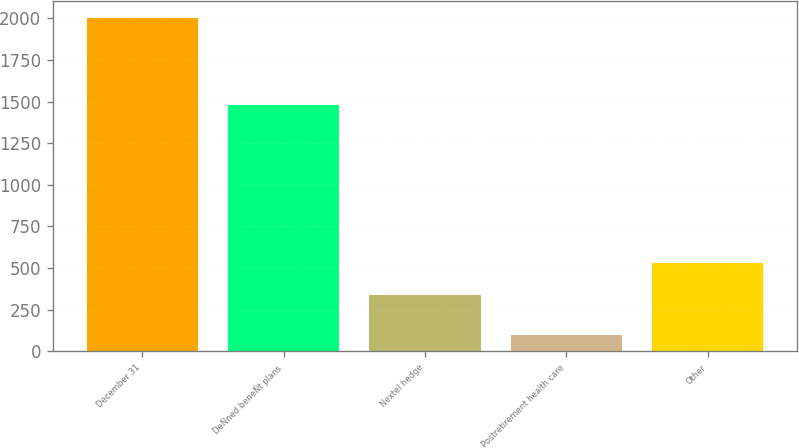Convert chart. <chart><loc_0><loc_0><loc_500><loc_500><bar_chart><fcel>December 31<fcel>DeÑned beneÑt plans<fcel>Nextel hedge<fcel>Postretirement health care<fcel>Other<nl><fcel>2004<fcel>1481<fcel>340<fcel>100<fcel>530.4<nl></chart> 